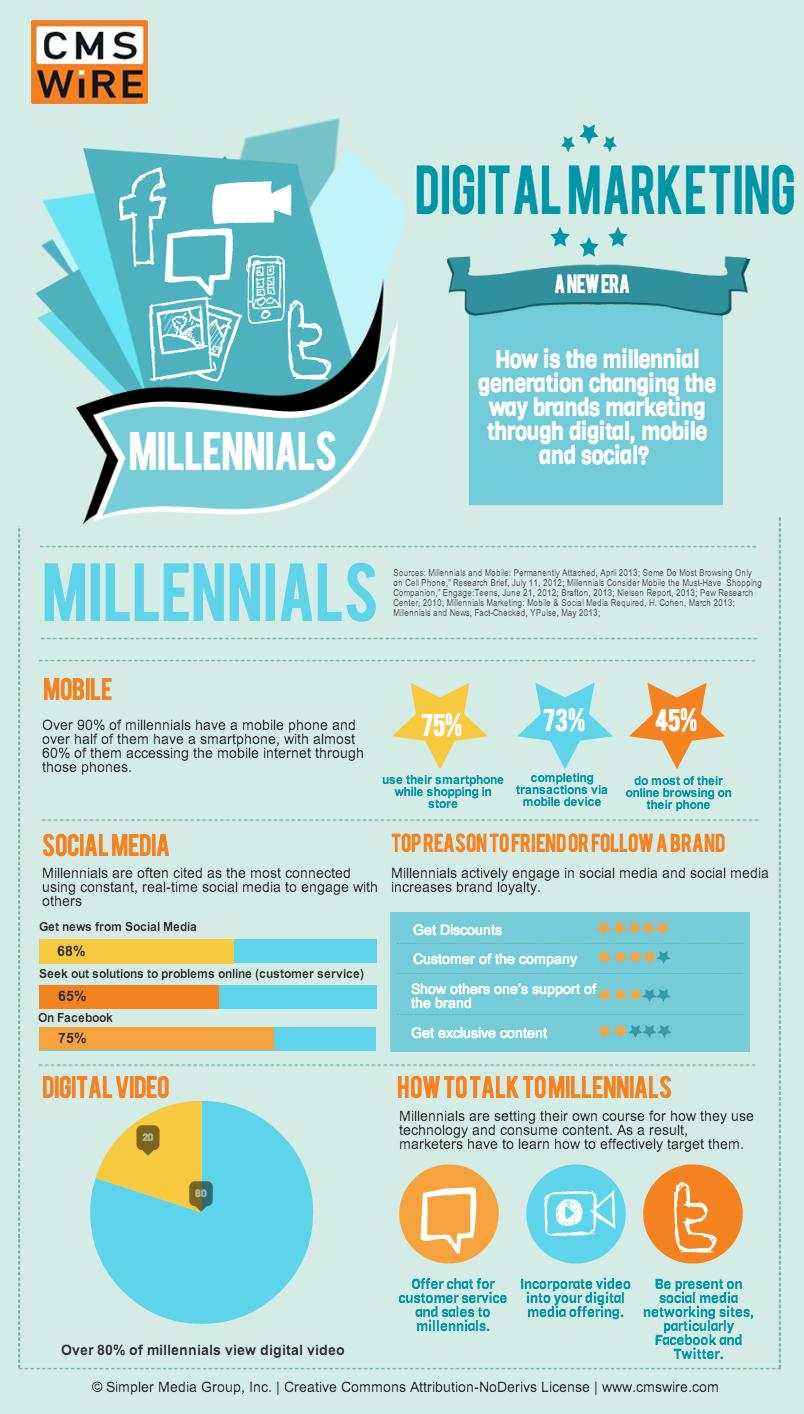Point out several critical features in this image. According to a recent survey, a significant percentage of millennials are not interested in digital videos. A recent survey found that only 32% of millennials use social media as their main source of news. The number of star ratings given for the phrase "Get exclusive content" is two. It is estimated that approximately 25% of millennials are not using Facebook. According to a recent study, 45% of millennials primarily use their phones for all forms of internet browsing. 